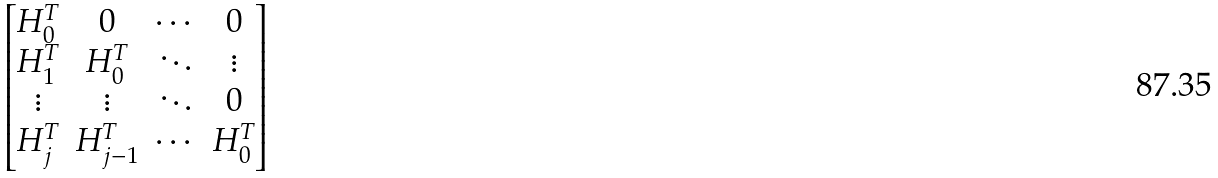Convert formula to latex. <formula><loc_0><loc_0><loc_500><loc_500>\begin{bmatrix} H _ { 0 } ^ { T } & 0 & \cdots & 0 \\ H _ { 1 } ^ { T } & H _ { 0 } ^ { T } & \ddots & \vdots \\ \vdots & \vdots & \ddots & 0 \\ H _ { j } ^ { T } & H _ { j - 1 } ^ { T } & \cdots & H _ { 0 } ^ { T } \end{bmatrix}</formula> 